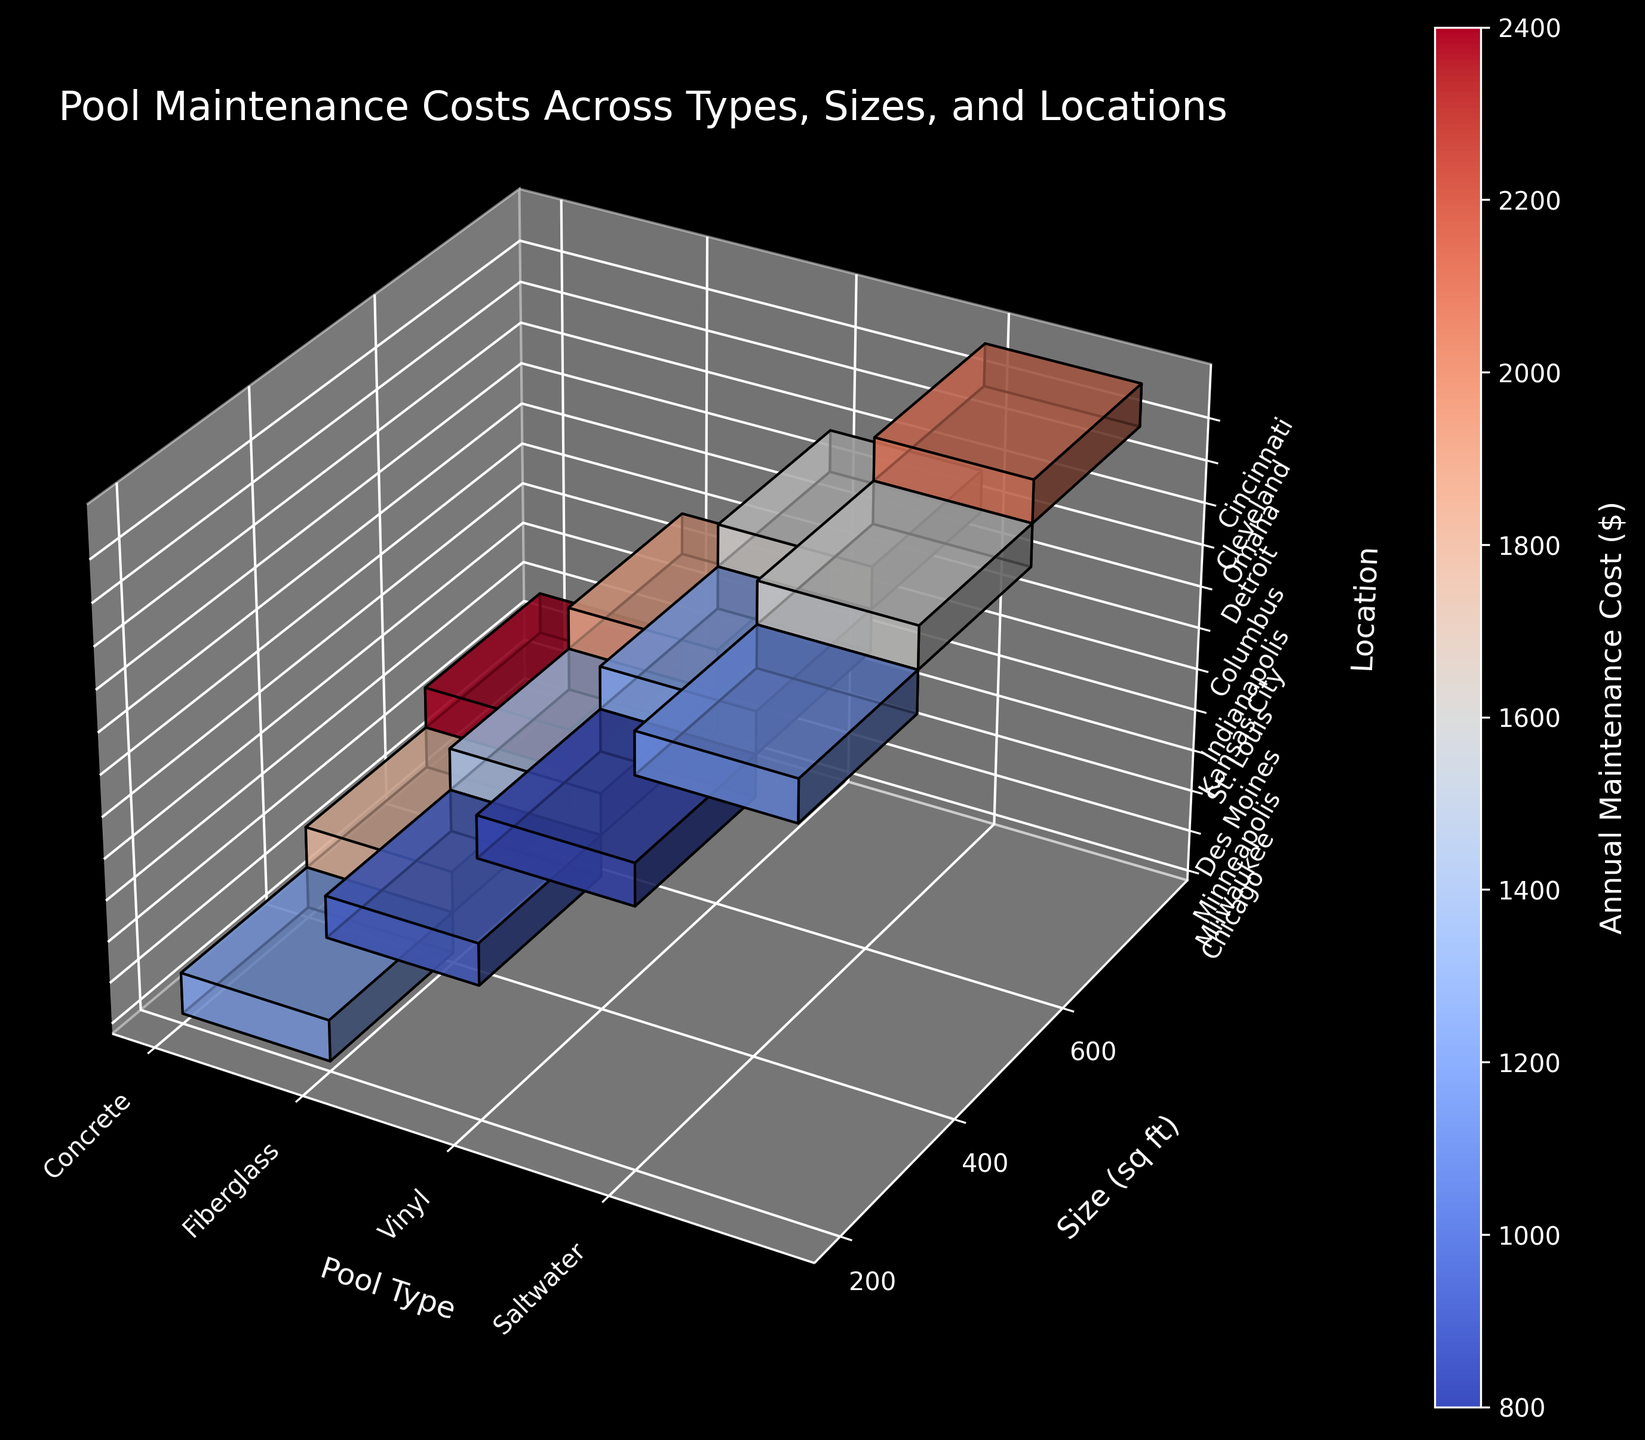What's the title of the figure? The title of the figure is usually displayed at the top and gives an overview of the content. By looking at the top of the figure, you can see it states, "Pool Maintenance Costs Across Types, Sizes, and Locations."
Answer: Pool Maintenance Costs Across Types, Sizes, and Locations What are the axes labels in the figure? The axes labels provide information about what each axis represents in a 3D plot. By examining each axis, we see that the x-axis is labeled 'Pool Type,' the y-axis is labeled 'Size (sq ft),' and the z-axis is labeled 'Location.'
Answer: Pool Type, Size (sq ft), Location Which pool type has the highest annual maintenance cost for the largest size? By looking at the largest size category on the y-axis and finding the highest annual maintenance cost, we see that for size 600 sq ft, Concrete pools have the highest cost.
Answer: Concrete Which pool type in Chicago has the lowest annual maintenance cost? By locating Chicago on the z-axis and finding the pool types, we see that the only pool type listed for this city has an annual maintenance cost. Therefore, Concrete is the answer as no other pool types are available.
Answer: Concrete Compare the annual maintenance cost for Saltwater pools in Cleveland and Cincinnati. Which one is higher? By looking at the Saltwater pool type and comparing the values for Cleveland and Cincinnati: Cleveland has a cost of $1600 and Cincinnati has a cost of $2100. Therefore, Cincinnati has the higher cost.
Answer: Cincinnati What is the average annual maintenance cost for all Vinyl pools? Locate all Vinyl pools in the figure and sum up their annual maintenance costs: 800 + 1200 + 1600. Divide by the number of Vinyl pools, which is 3. The average cost is (800 + 1200 + 1600) / 3 = 1200.
Answer: 1200 Which pool type shows the most variety in annual maintenance costs across different sizes? By examining the color gradients for each pool type across different sizes, we see Concrete shows significant variation as the maintenance cost goes from $1200 to $2400, making it the most diverse.
Answer: Concrete What is the difference in maintenance costs between Concrete and Fiberglass pools of 400 sq ft in different cities? Locate the values for 400 sq ft Concrete and Fiberglass pools. Concrete values: $1800 (Milwaukee). Fiberglass values: $1400 (St. Louis). Difference: $1800 - $1400 = $400.
Answer: 400 Which type and size of pools are generally the cheapest to maintain annually in the Midwest region according to the figure? By examining all pool types and sizes, Vinyl pools tend to have lower annual maintenance costs, with 200 sq ft size being especially affordable ($800 in Indianapolis).
Answer: Vinyl, 200 sq ft Can you identify any patterns or trends related to the size of the pool and maintenance costs? Generally, as pool size increases (moving up on the y-axis), the maintenance cost also tends to increase. This trend is noticeable across almost all pool types and locations in the figure.
Answer: Increasing size leads to higher costs 